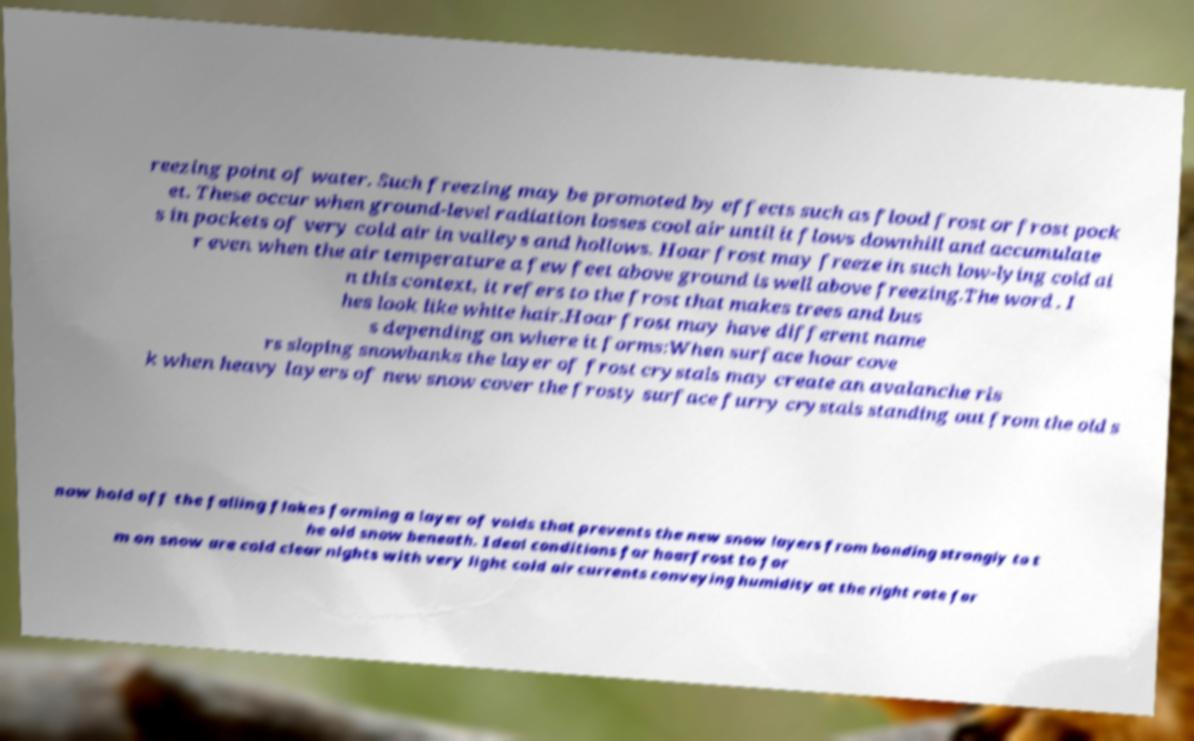For documentation purposes, I need the text within this image transcribed. Could you provide that? reezing point of water. Such freezing may be promoted by effects such as flood frost or frost pock et. These occur when ground-level radiation losses cool air until it flows downhill and accumulate s in pockets of very cold air in valleys and hollows. Hoar frost may freeze in such low-lying cold ai r even when the air temperature a few feet above ground is well above freezing.The word . I n this context, it refers to the frost that makes trees and bus hes look like white hair.Hoar frost may have different name s depending on where it forms:When surface hoar cove rs sloping snowbanks the layer of frost crystals may create an avalanche ris k when heavy layers of new snow cover the frosty surface furry crystals standing out from the old s now hold off the falling flakes forming a layer of voids that prevents the new snow layers from bonding strongly to t he old snow beneath. Ideal conditions for hoarfrost to for m on snow are cold clear nights with very light cold air currents conveying humidity at the right rate for 